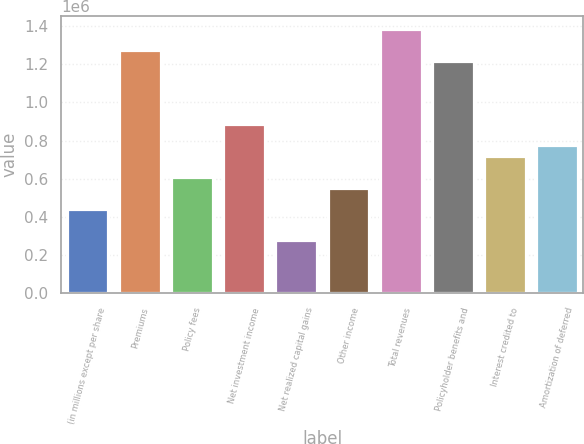<chart> <loc_0><loc_0><loc_500><loc_500><bar_chart><fcel>(in millions except per share<fcel>Premiums<fcel>Policy fees<fcel>Net investment income<fcel>Net realized capital gains<fcel>Other income<fcel>Total revenues<fcel>Policyholder benefits and<fcel>Interest credited to<fcel>Amortization of deferred<nl><fcel>442443<fcel>1.27202e+06<fcel>608359<fcel>884886<fcel>276527<fcel>553054<fcel>1.38263e+06<fcel>1.21672e+06<fcel>718970<fcel>774275<nl></chart> 